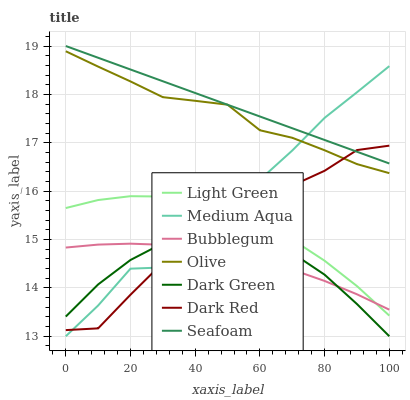Does Dark Green have the minimum area under the curve?
Answer yes or no. Yes. Does Seafoam have the maximum area under the curve?
Answer yes or no. Yes. Does Bubblegum have the minimum area under the curve?
Answer yes or no. No. Does Bubblegum have the maximum area under the curve?
Answer yes or no. No. Is Seafoam the smoothest?
Answer yes or no. Yes. Is Medium Aqua the roughest?
Answer yes or no. Yes. Is Bubblegum the smoothest?
Answer yes or no. No. Is Bubblegum the roughest?
Answer yes or no. No. Does Medium Aqua have the lowest value?
Answer yes or no. Yes. Does Bubblegum have the lowest value?
Answer yes or no. No. Does Seafoam have the highest value?
Answer yes or no. Yes. Does Bubblegum have the highest value?
Answer yes or no. No. Is Bubblegum less than Seafoam?
Answer yes or no. Yes. Is Seafoam greater than Dark Green?
Answer yes or no. Yes. Does Bubblegum intersect Medium Aqua?
Answer yes or no. Yes. Is Bubblegum less than Medium Aqua?
Answer yes or no. No. Is Bubblegum greater than Medium Aqua?
Answer yes or no. No. Does Bubblegum intersect Seafoam?
Answer yes or no. No. 